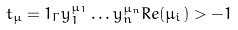Convert formula to latex. <formula><loc_0><loc_0><loc_500><loc_500>t _ { \mu } = 1 _ { \Gamma } y _ { 1 } ^ { \mu _ { 1 } } \dots y _ { n } ^ { \mu _ { n } } R e ( \mu _ { i } ) > - 1</formula> 